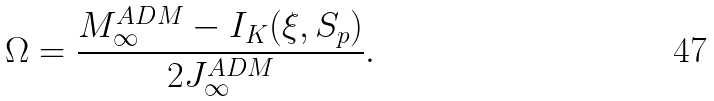<formula> <loc_0><loc_0><loc_500><loc_500>\Omega = \frac { M ^ { A D M } _ { \infty } - I _ { K } ( \xi , S _ { p } ) } { 2 J ^ { A D M } _ { \infty } } .</formula> 